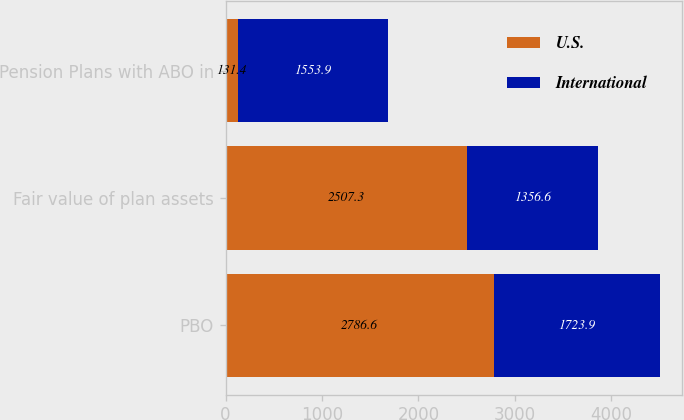Convert chart to OTSL. <chart><loc_0><loc_0><loc_500><loc_500><stacked_bar_chart><ecel><fcel>PBO<fcel>Fair value of plan assets<fcel>Pension Plans with ABO in<nl><fcel>U.S.<fcel>2786.6<fcel>2507.3<fcel>131.4<nl><fcel>International<fcel>1723.9<fcel>1356.6<fcel>1553.9<nl></chart> 